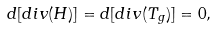Convert formula to latex. <formula><loc_0><loc_0><loc_500><loc_500>d [ d i v ( H ) ] = d [ d i v ( T _ { g } ) ] = 0 ,</formula> 